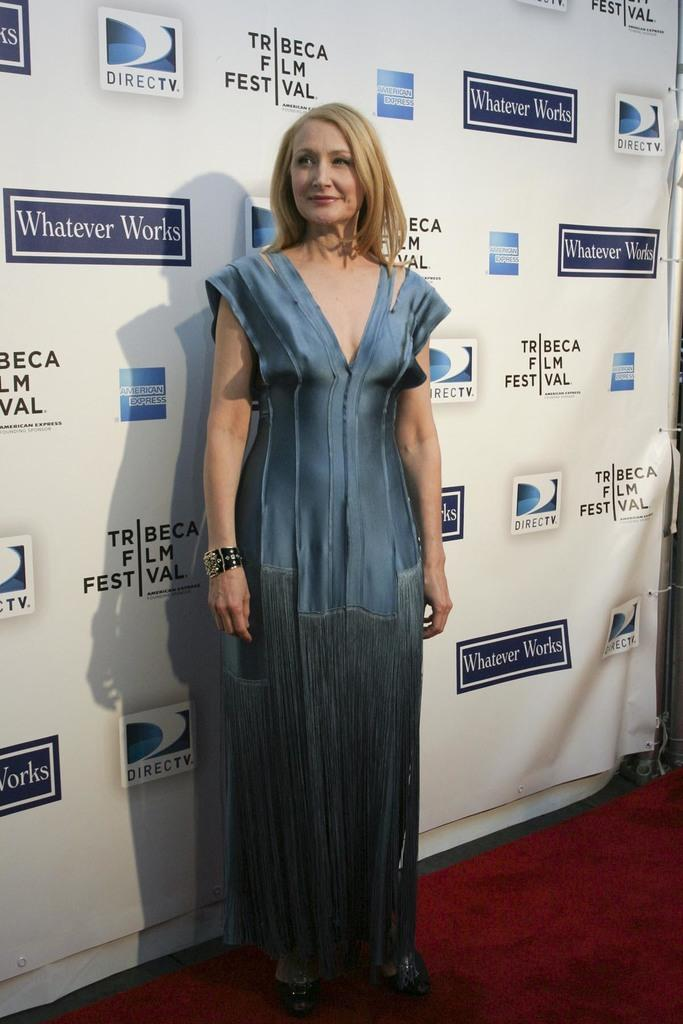Who is the main subject in the image? There is a woman in the image. What is the woman doing in the image? The woman is standing and posing for the camera. What can be seen behind the woman in the image? There is a banner behind the woman. What type of air can be seen coming out of the woman's toe in the image? There is no air or toe visible in the image; it only shows a woman standing and posing for the camera with a banner behind her. 